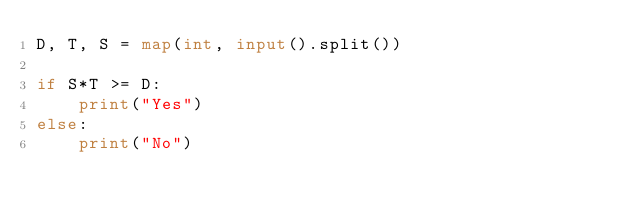<code> <loc_0><loc_0><loc_500><loc_500><_Python_>D, T, S = map(int, input().split())

if S*T >= D:
    print("Yes")
else:
    print("No")</code> 